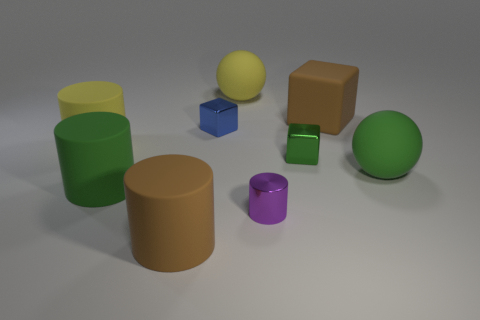Add 1 green metallic objects. How many objects exist? 10 Subtract all green metallic blocks. How many blocks are left? 2 Subtract all balls. How many objects are left? 7 Subtract 2 cubes. How many cubes are left? 1 Subtract all big gray metallic objects. Subtract all big brown cylinders. How many objects are left? 8 Add 7 tiny blue objects. How many tiny blue objects are left? 8 Add 5 matte balls. How many matte balls exist? 7 Subtract all yellow cylinders. How many cylinders are left? 3 Subtract 1 green cubes. How many objects are left? 8 Subtract all red blocks. Subtract all yellow cylinders. How many blocks are left? 3 